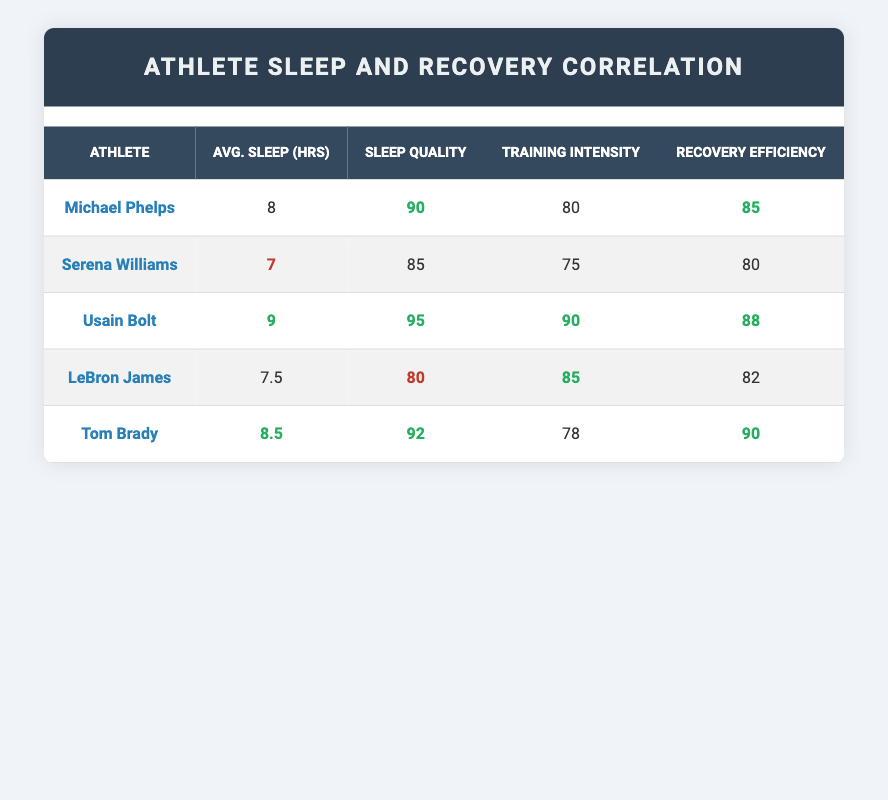What is the average sleep hours for the athletes listed? To find the average sleep hours, we sum the sleep hours of all athletes: 8 + 7 + 9 + 7.5 + 8.5 = 40. The total number of athletes is 5. Therefore, the average sleep hours = 40 / 5 = 8.
Answer: 8 Which athlete has the highest sleep quality score? Looking at the table, Usain Bolt has the highest sleep quality score of 95.
Answer: Usain Bolt Is there a correlation between sleep quality score and recovery efficiency for the given athletes? Analyzing the table, higher sleep quality scores generally correspond to higher recovery efficiency scores. For instance, Usain Bolt (95) has 88, Tom Brady (92) has 90, and Michael Phelps (90) has 85. Thus, there appears to be a positive correlation.
Answer: Yes What is the difference in recovery efficiency between the highest and the lowest recovery efficiency athletes? The highest recovery efficiency is Tom Brady at 90 and the lowest is Serena Williams at 80. The difference is 90 - 80 = 10.
Answer: 10 If we consider the athletes with average sleep hours above 8, how many of them have a recovery efficiency greater than 85? The athletes with average sleep hours above 8 are Usain Bolt (9 hours) and Tom Brady (8.5 hours). Tom Brady has a recovery efficiency of 90, which is above 85, while Usain Bolt's efficiency is 88. Both have efficiencies above 85.
Answer: 2 Which athlete has the lowest training intensity score and what is that score? The lowest training intensity score in the table belongs to Serena Williams with a score of 75.
Answer: 75 If an athlete sleeps less than 8 hours, what is the average recovery efficiency of those athletes? The athletes who sleep less than 8 hours are Serena Williams (7), LeBron James (7.5). Their recovery efficiencies are 80 (Serena) and 82 (LeBron). The average is (80 + 82) / 2 = 81.
Answer: 81 Is there an athlete who sleeps more than 8 hours but does not have the highest recovery efficiency? Yes, Usain Bolt sleeps 9 hours and has a recovery efficiency of 88, which is not the highest (which is Tom Brady at 90).
Answer: Yes 